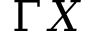<formula> <loc_0><loc_0><loc_500><loc_500>\Gamma X</formula> 